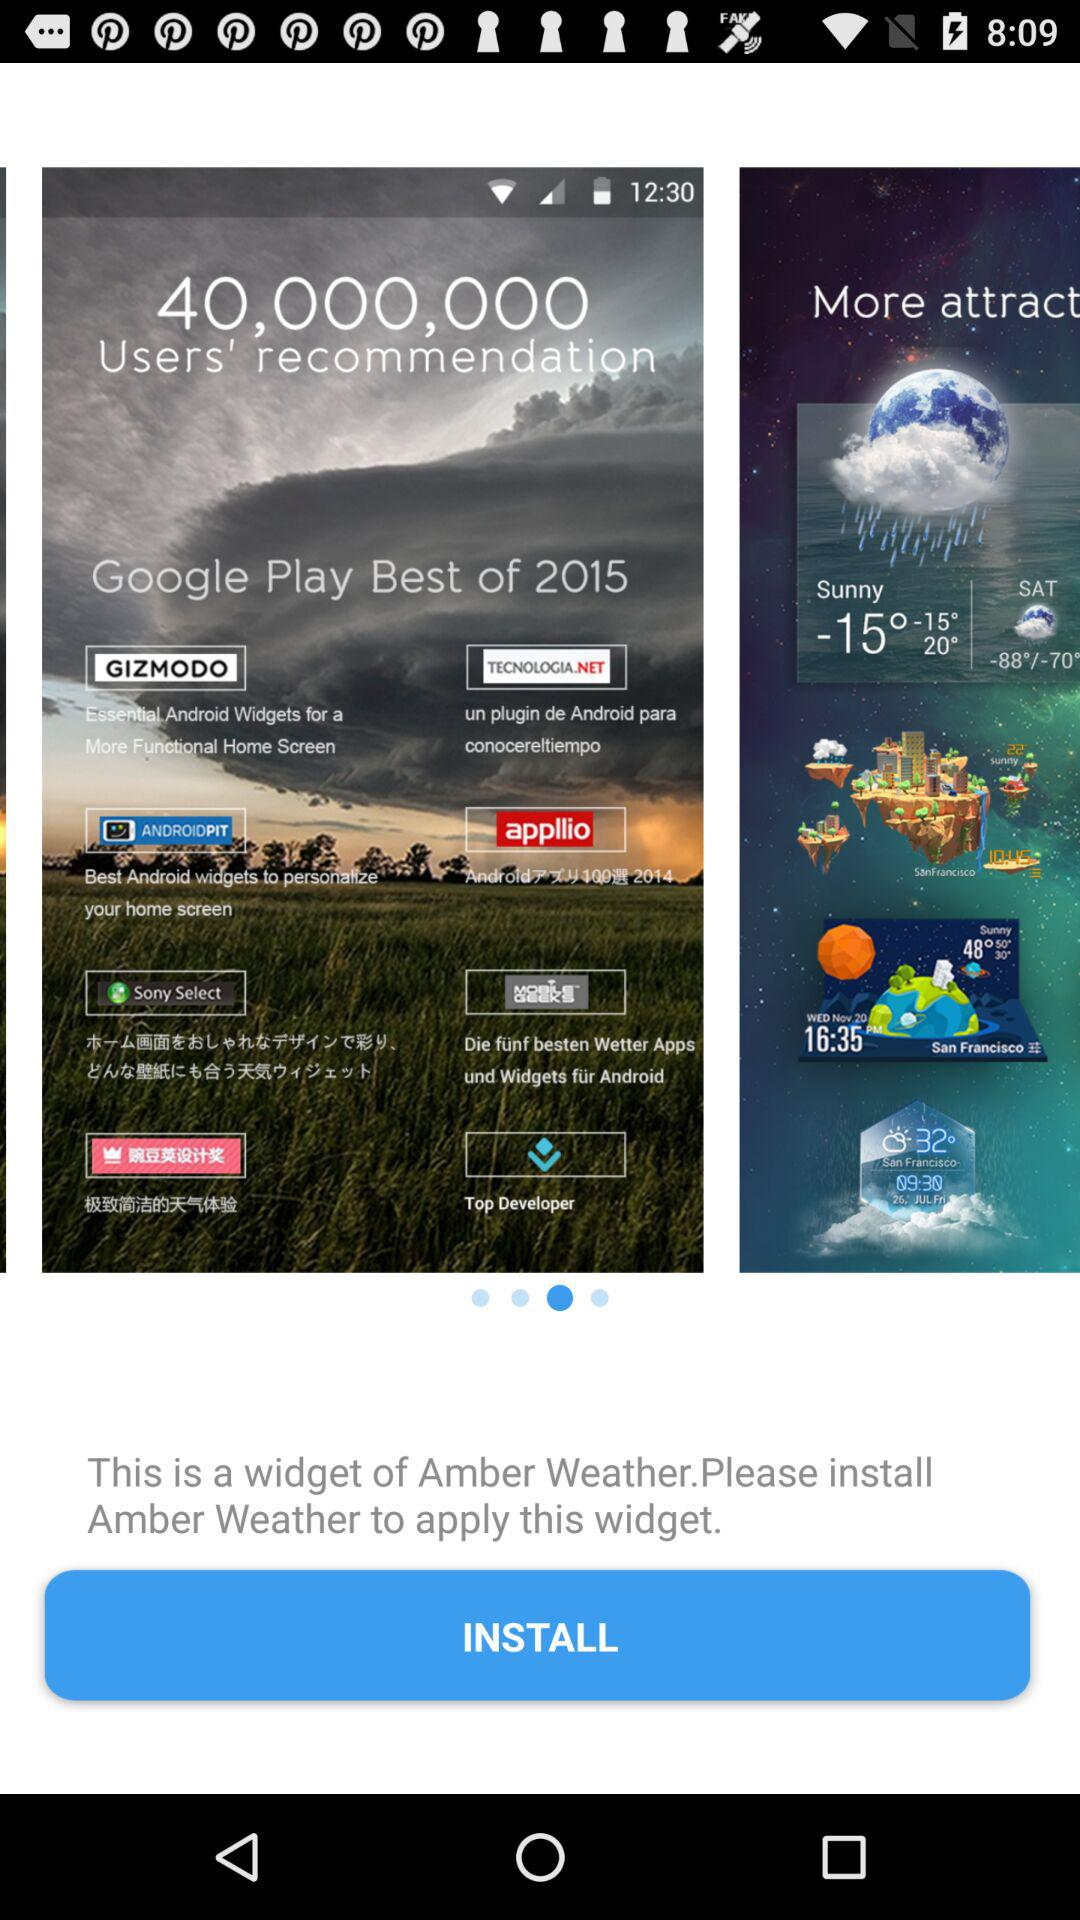What's the weather?
When the provided information is insufficient, respond with <no answer>. <no answer> 